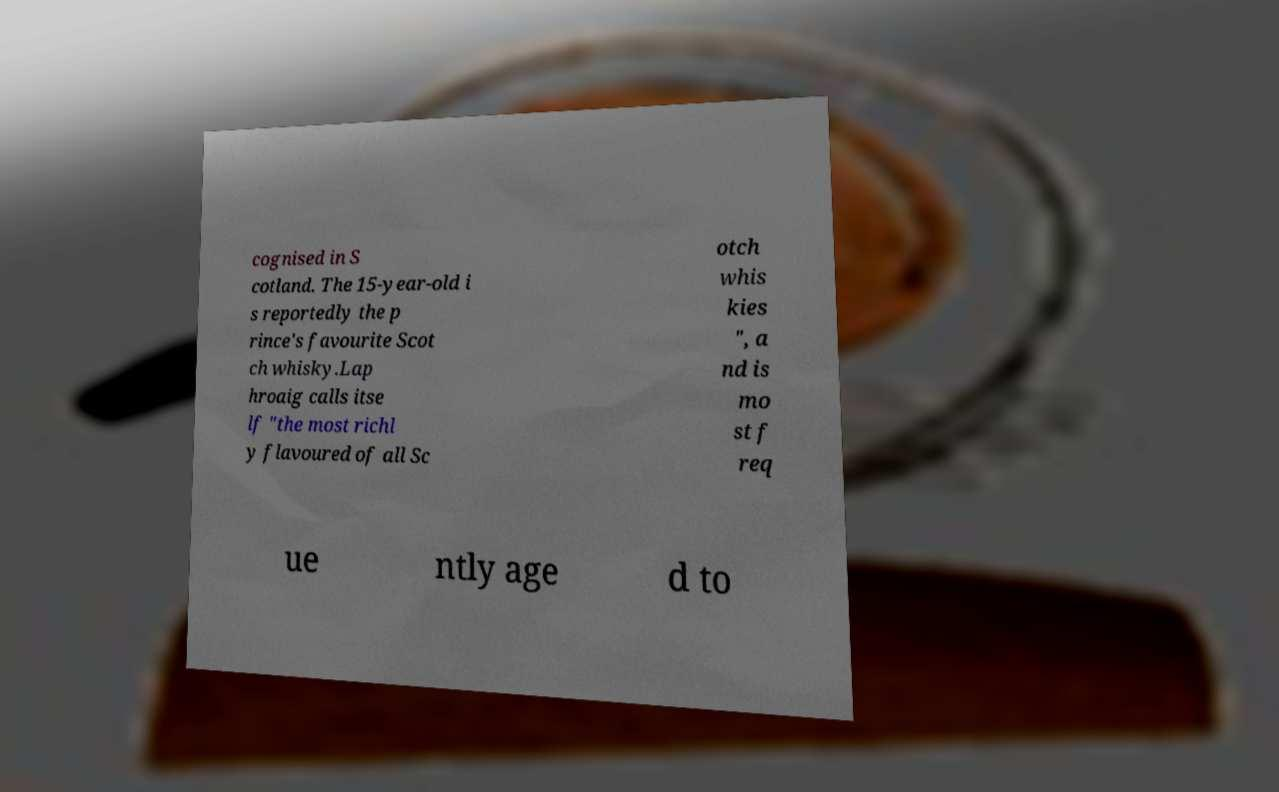Could you assist in decoding the text presented in this image and type it out clearly? cognised in S cotland. The 15-year-old i s reportedly the p rince's favourite Scot ch whisky.Lap hroaig calls itse lf "the most richl y flavoured of all Sc otch whis kies ", a nd is mo st f req ue ntly age d to 